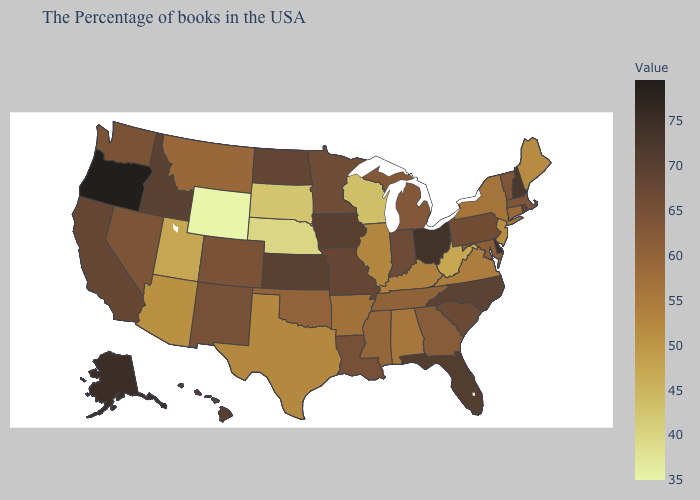Among the states that border South Carolina , does North Carolina have the lowest value?
Quick response, please. No. Which states have the lowest value in the Northeast?
Give a very brief answer. New Jersey. Does Virginia have a higher value than Nebraska?
Quick response, please. Yes. Which states have the highest value in the USA?
Concise answer only. Oregon. Which states have the lowest value in the USA?
Quick response, please. Wyoming. Among the states that border Wyoming , which have the highest value?
Short answer required. Idaho. Is the legend a continuous bar?
Quick response, please. Yes. Which states hav the highest value in the South?
Concise answer only. Delaware. 